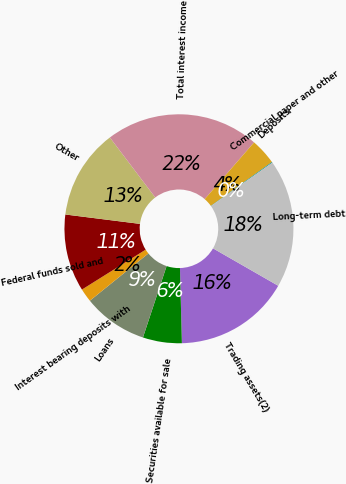<chart> <loc_0><loc_0><loc_500><loc_500><pie_chart><fcel>Trading assets(2)<fcel>Securities available for sale<fcel>Loans<fcel>Interest bearing deposits with<fcel>Federal funds sold and<fcel>Other<fcel>Total interest income<fcel>Deposits<fcel>Commercial paper and other<fcel>Long-term debt<nl><fcel>16.3%<fcel>5.5%<fcel>9.1%<fcel>1.9%<fcel>10.9%<fcel>12.7%<fcel>21.7%<fcel>3.7%<fcel>0.1%<fcel>18.1%<nl></chart> 